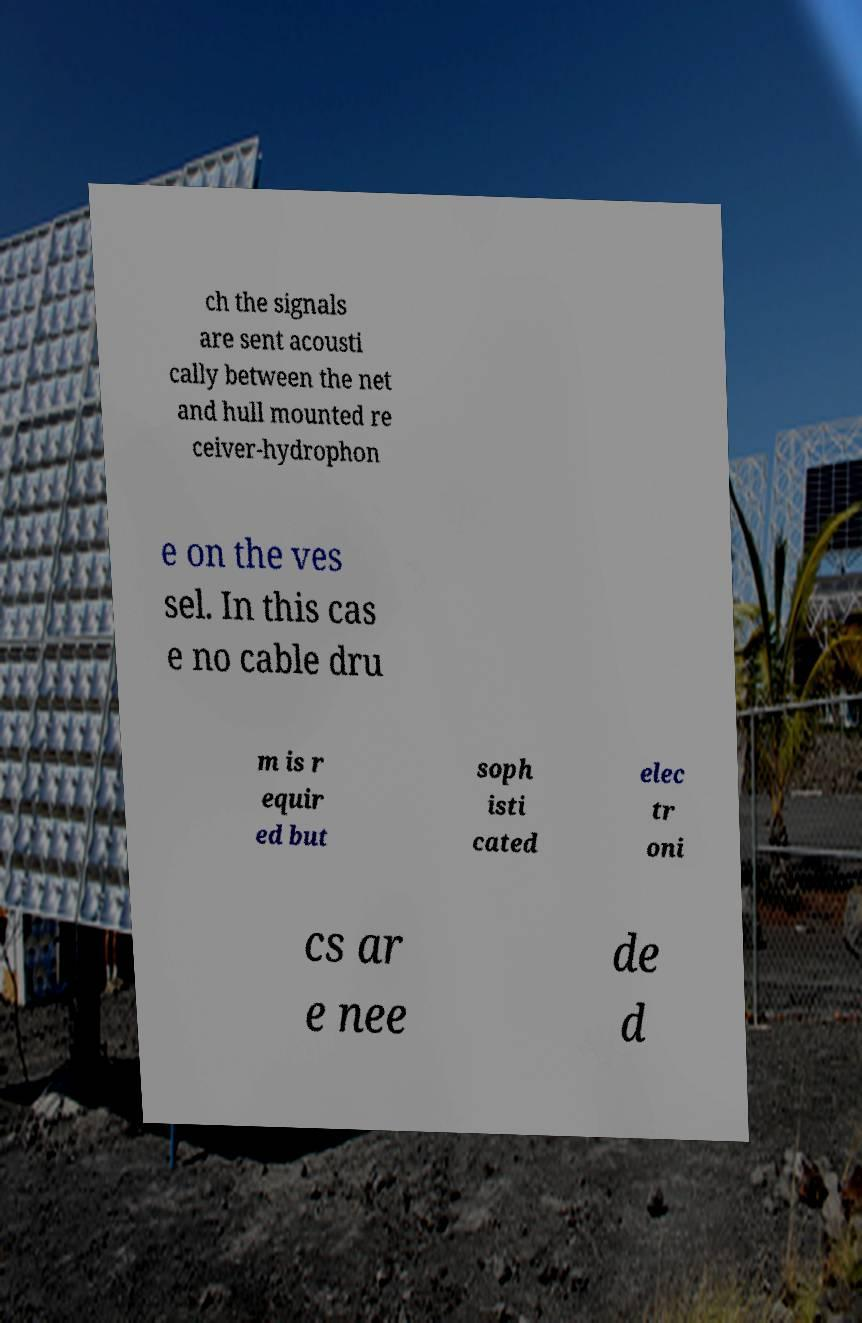Could you assist in decoding the text presented in this image and type it out clearly? ch the signals are sent acousti cally between the net and hull mounted re ceiver-hydrophon e on the ves sel. In this cas e no cable dru m is r equir ed but soph isti cated elec tr oni cs ar e nee de d 